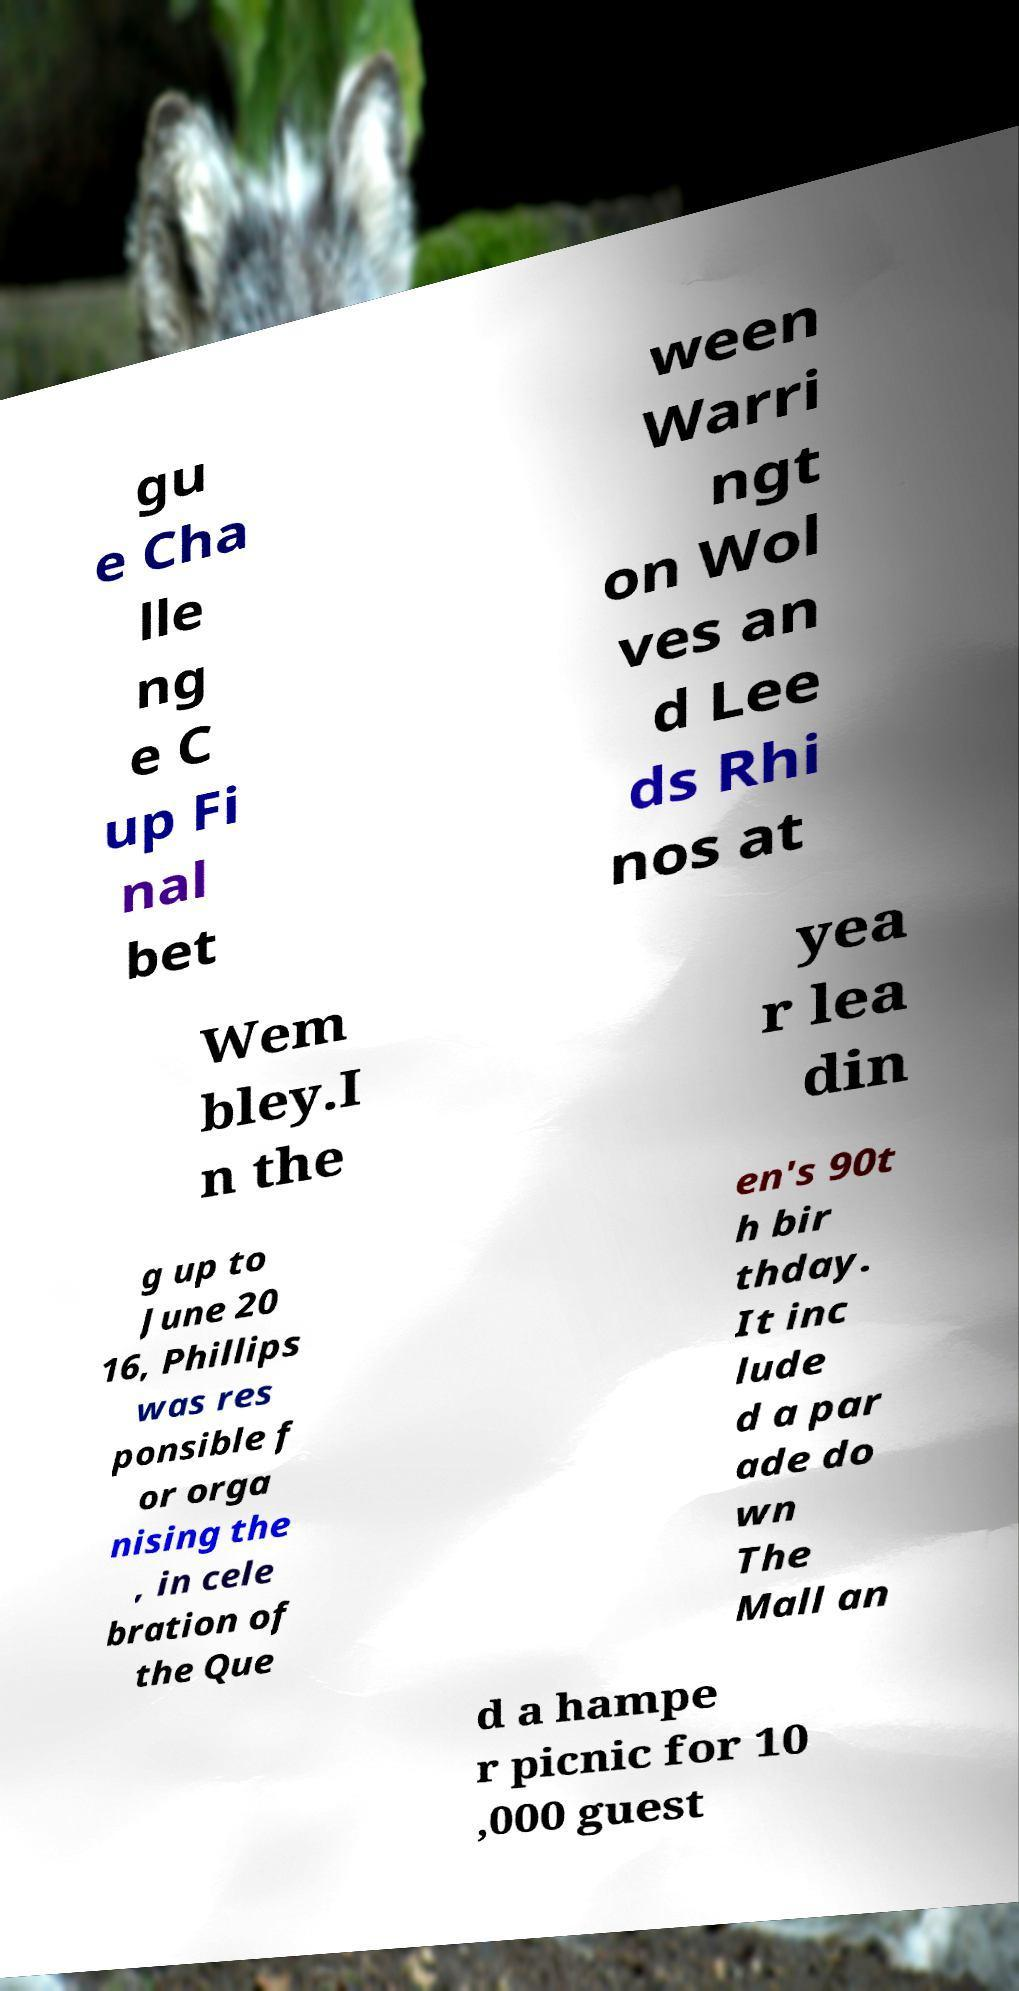Please read and relay the text visible in this image. What does it say? gu e Cha lle ng e C up Fi nal bet ween Warri ngt on Wol ves an d Lee ds Rhi nos at Wem bley.I n the yea r lea din g up to June 20 16, Phillips was res ponsible f or orga nising the , in cele bration of the Que en's 90t h bir thday. It inc lude d a par ade do wn The Mall an d a hampe r picnic for 10 ,000 guest 